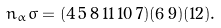Convert formula to latex. <formula><loc_0><loc_0><loc_500><loc_500>n _ { \alpha } \sigma = ( 4 \, 5 \, 8 \, 1 1 \, 1 0 \, 7 ) ( 6 \, 9 ) ( 1 2 ) .</formula> 